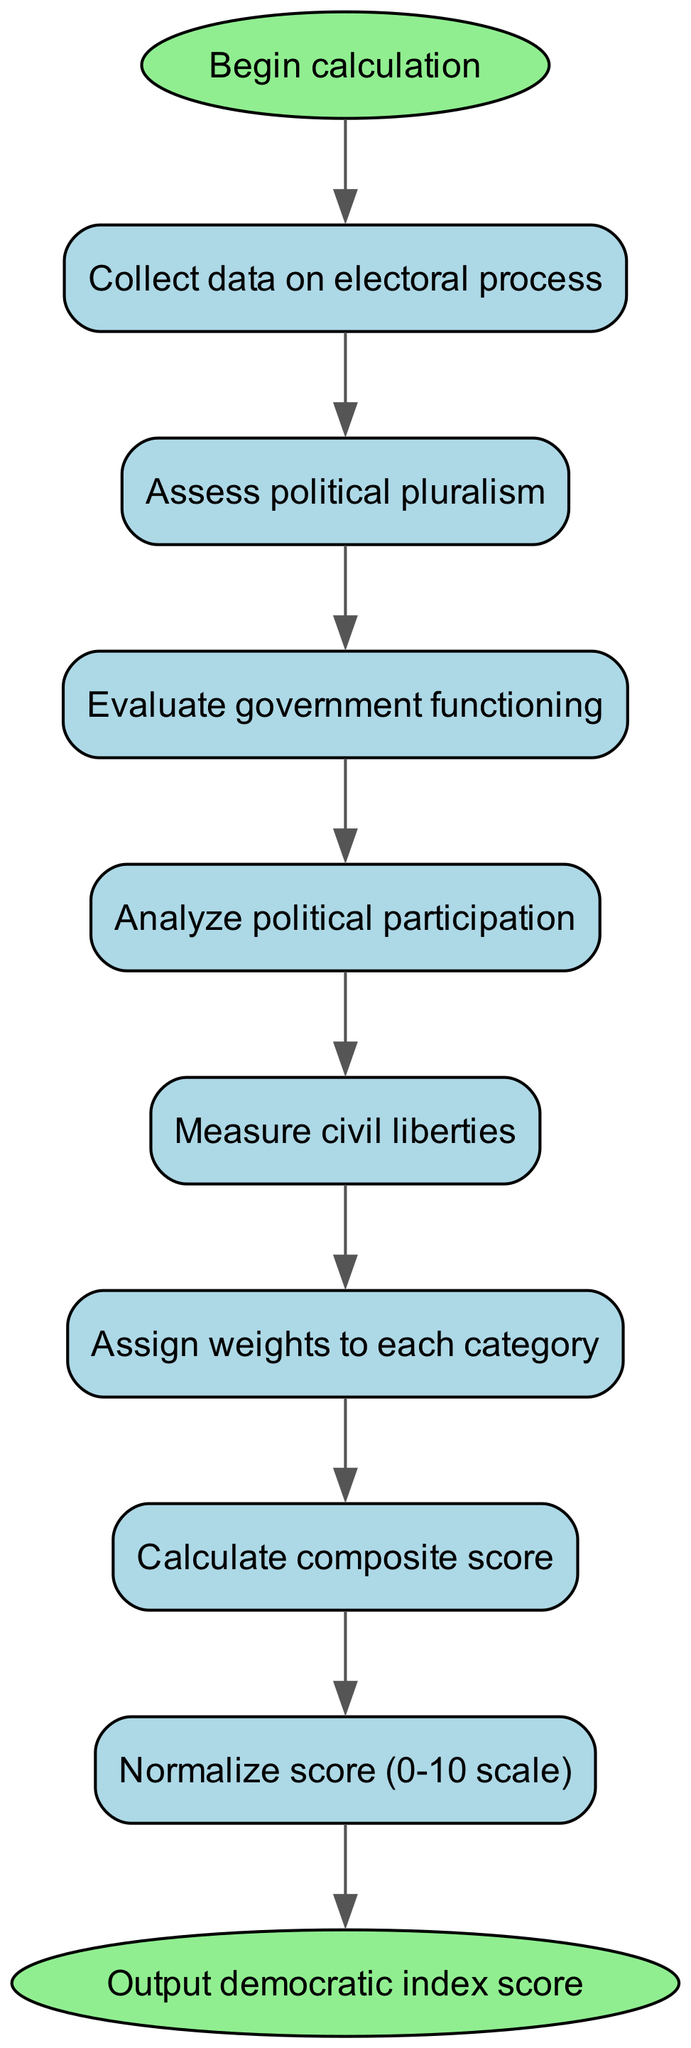What is the first step in the algorithm? The first step is labeled as "Collect data on electoral process" which is the first node after the start node in the flowchart.
Answer: Collect data on electoral process How many nodes are present in the diagram? There are eight nodes present that represent distinct steps in the algorithm, including the start and end nodes.
Answer: 8 What is the last step before outputting the democratic index score? The last step before reaching the end node is "Normalize score (0-10 scale)" which is the eighth node in the flowchart.
Answer: Normalize score (0-10 scale) What process follows the evaluation of government functioning? After "Evaluate government functioning," the next process is "Analyze political participation," which is the fourth node in the flowchart.
Answer: Analyze political participation How many edges connect the nodes in the flowchart? The flowchart contains seven edges connecting the eight nodes, including the connection from the last node to the end node.
Answer: 7 What is the relationship between assessing political pluralism and measuring civil liberties? "Assess political pluralism" leads directly to "Measure civil liberties." This indicates that after evaluating political pluralism, measuring civil liberties is the subsequent step in the algorithm.
Answer: Direct connection Which node precedes the assignment of weights to each category? The node that precedes "Assign weights to each category" is "Measure civil liberties," showing the sequence and dependencies of the steps.
Answer: Measure civil liberties What is the outcome of the whole process? The final output of the process is specified as "Output democratic index score," stated in the end node of the flowchart.
Answer: Output democratic index score 